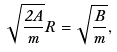Convert formula to latex. <formula><loc_0><loc_0><loc_500><loc_500>\sqrt { \frac { 2 A } { m } } R = \sqrt { \frac { B } { m } } ,</formula> 